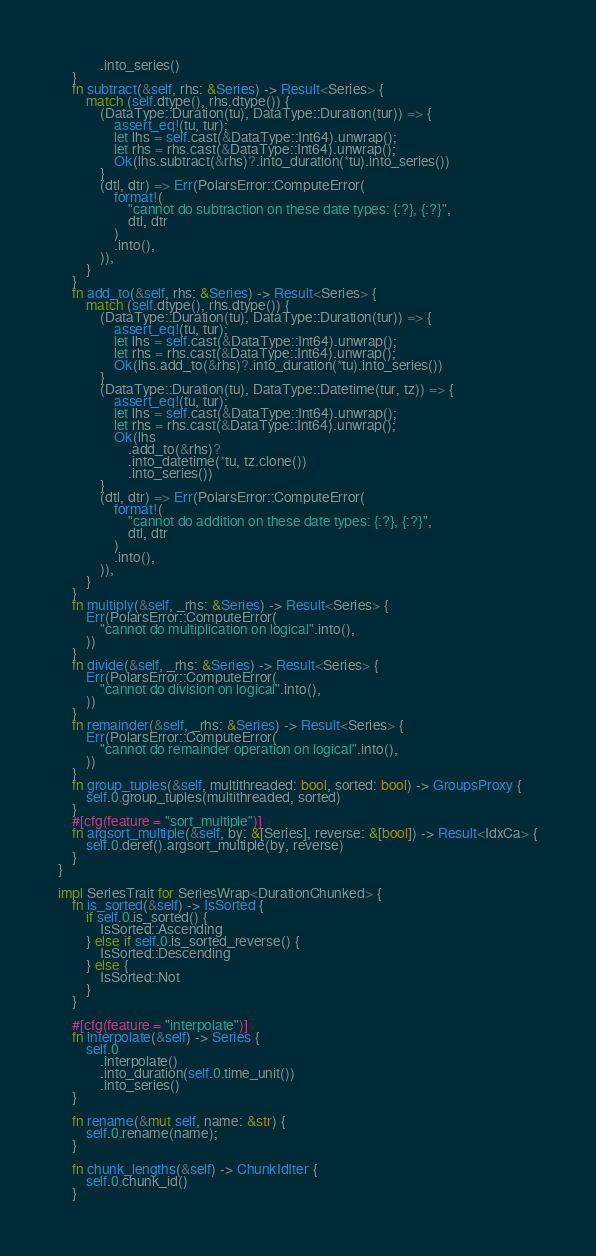<code> <loc_0><loc_0><loc_500><loc_500><_Rust_>            .into_series()
    }
    fn subtract(&self, rhs: &Series) -> Result<Series> {
        match (self.dtype(), rhs.dtype()) {
            (DataType::Duration(tu), DataType::Duration(tur)) => {
                assert_eq!(tu, tur);
                let lhs = self.cast(&DataType::Int64).unwrap();
                let rhs = rhs.cast(&DataType::Int64).unwrap();
                Ok(lhs.subtract(&rhs)?.into_duration(*tu).into_series())
            }
            (dtl, dtr) => Err(PolarsError::ComputeError(
                format!(
                    "cannot do subtraction on these date types: {:?}, {:?}",
                    dtl, dtr
                )
                .into(),
            )),
        }
    }
    fn add_to(&self, rhs: &Series) -> Result<Series> {
        match (self.dtype(), rhs.dtype()) {
            (DataType::Duration(tu), DataType::Duration(tur)) => {
                assert_eq!(tu, tur);
                let lhs = self.cast(&DataType::Int64).unwrap();
                let rhs = rhs.cast(&DataType::Int64).unwrap();
                Ok(lhs.add_to(&rhs)?.into_duration(*tu).into_series())
            }
            (DataType::Duration(tu), DataType::Datetime(tur, tz)) => {
                assert_eq!(tu, tur);
                let lhs = self.cast(&DataType::Int64).unwrap();
                let rhs = rhs.cast(&DataType::Int64).unwrap();
                Ok(lhs
                    .add_to(&rhs)?
                    .into_datetime(*tu, tz.clone())
                    .into_series())
            }
            (dtl, dtr) => Err(PolarsError::ComputeError(
                format!(
                    "cannot do addition on these date types: {:?}, {:?}",
                    dtl, dtr
                )
                .into(),
            )),
        }
    }
    fn multiply(&self, _rhs: &Series) -> Result<Series> {
        Err(PolarsError::ComputeError(
            "cannot do multiplication on logical".into(),
        ))
    }
    fn divide(&self, _rhs: &Series) -> Result<Series> {
        Err(PolarsError::ComputeError(
            "cannot do division on logical".into(),
        ))
    }
    fn remainder(&self, _rhs: &Series) -> Result<Series> {
        Err(PolarsError::ComputeError(
            "cannot do remainder operation on logical".into(),
        ))
    }
    fn group_tuples(&self, multithreaded: bool, sorted: bool) -> GroupsProxy {
        self.0.group_tuples(multithreaded, sorted)
    }
    #[cfg(feature = "sort_multiple")]
    fn argsort_multiple(&self, by: &[Series], reverse: &[bool]) -> Result<IdxCa> {
        self.0.deref().argsort_multiple(by, reverse)
    }
}

impl SeriesTrait for SeriesWrap<DurationChunked> {
    fn is_sorted(&self) -> IsSorted {
        if self.0.is_sorted() {
            IsSorted::Ascending
        } else if self.0.is_sorted_reverse() {
            IsSorted::Descending
        } else {
            IsSorted::Not
        }
    }

    #[cfg(feature = "interpolate")]
    fn interpolate(&self) -> Series {
        self.0
            .interpolate()
            .into_duration(self.0.time_unit())
            .into_series()
    }

    fn rename(&mut self, name: &str) {
        self.0.rename(name);
    }

    fn chunk_lengths(&self) -> ChunkIdIter {
        self.0.chunk_id()
    }</code> 